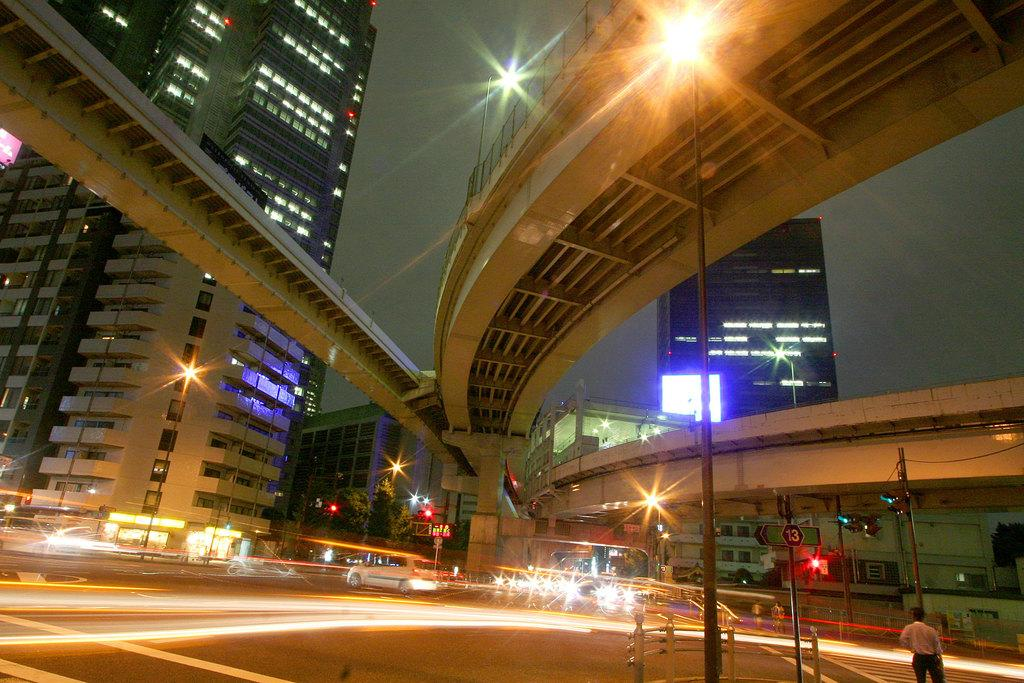What is the main subject of the image? The main subject of the image is a car on the road. What can be seen in the background of the image? The sky is visible in the background of the image. What type of structure is present in the image? There are buildings in the image. What is the person in the image doing? The facts do not specify what the person is doing. What other objects can be seen in the image? There are poles, lights, trees, a fence, a direction board, bridges, and some objects in the image. What type of cookware is the person using to gain approval in the image? There is no cookware or approval-seeking activity present in the image. How does the wind affect the movement of the car in the image? The facts do not mention any wind or its effect on the car's movement in the image. 